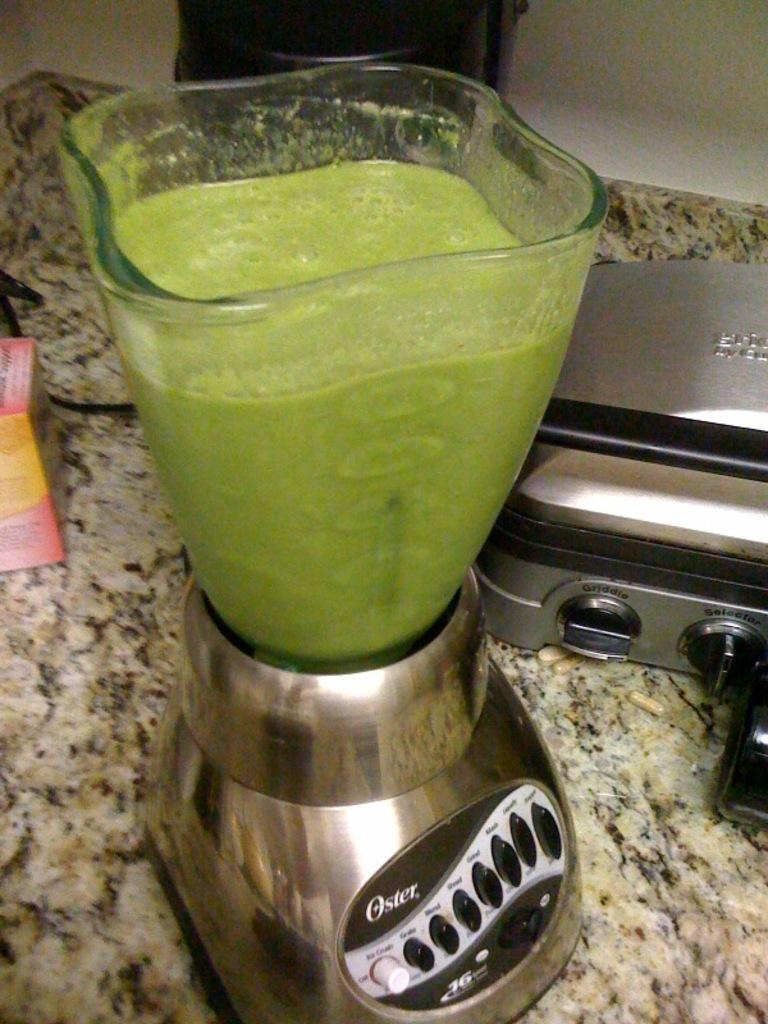<image>
Relay a brief, clear account of the picture shown. A silver blender full of green liquid says "Oster" on the base. 